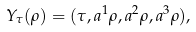<formula> <loc_0><loc_0><loc_500><loc_500>Y _ { \tau } ( \rho ) = ( \tau , a ^ { 1 } \rho , a ^ { 2 } \rho , a ^ { 3 } \rho ) ,</formula> 